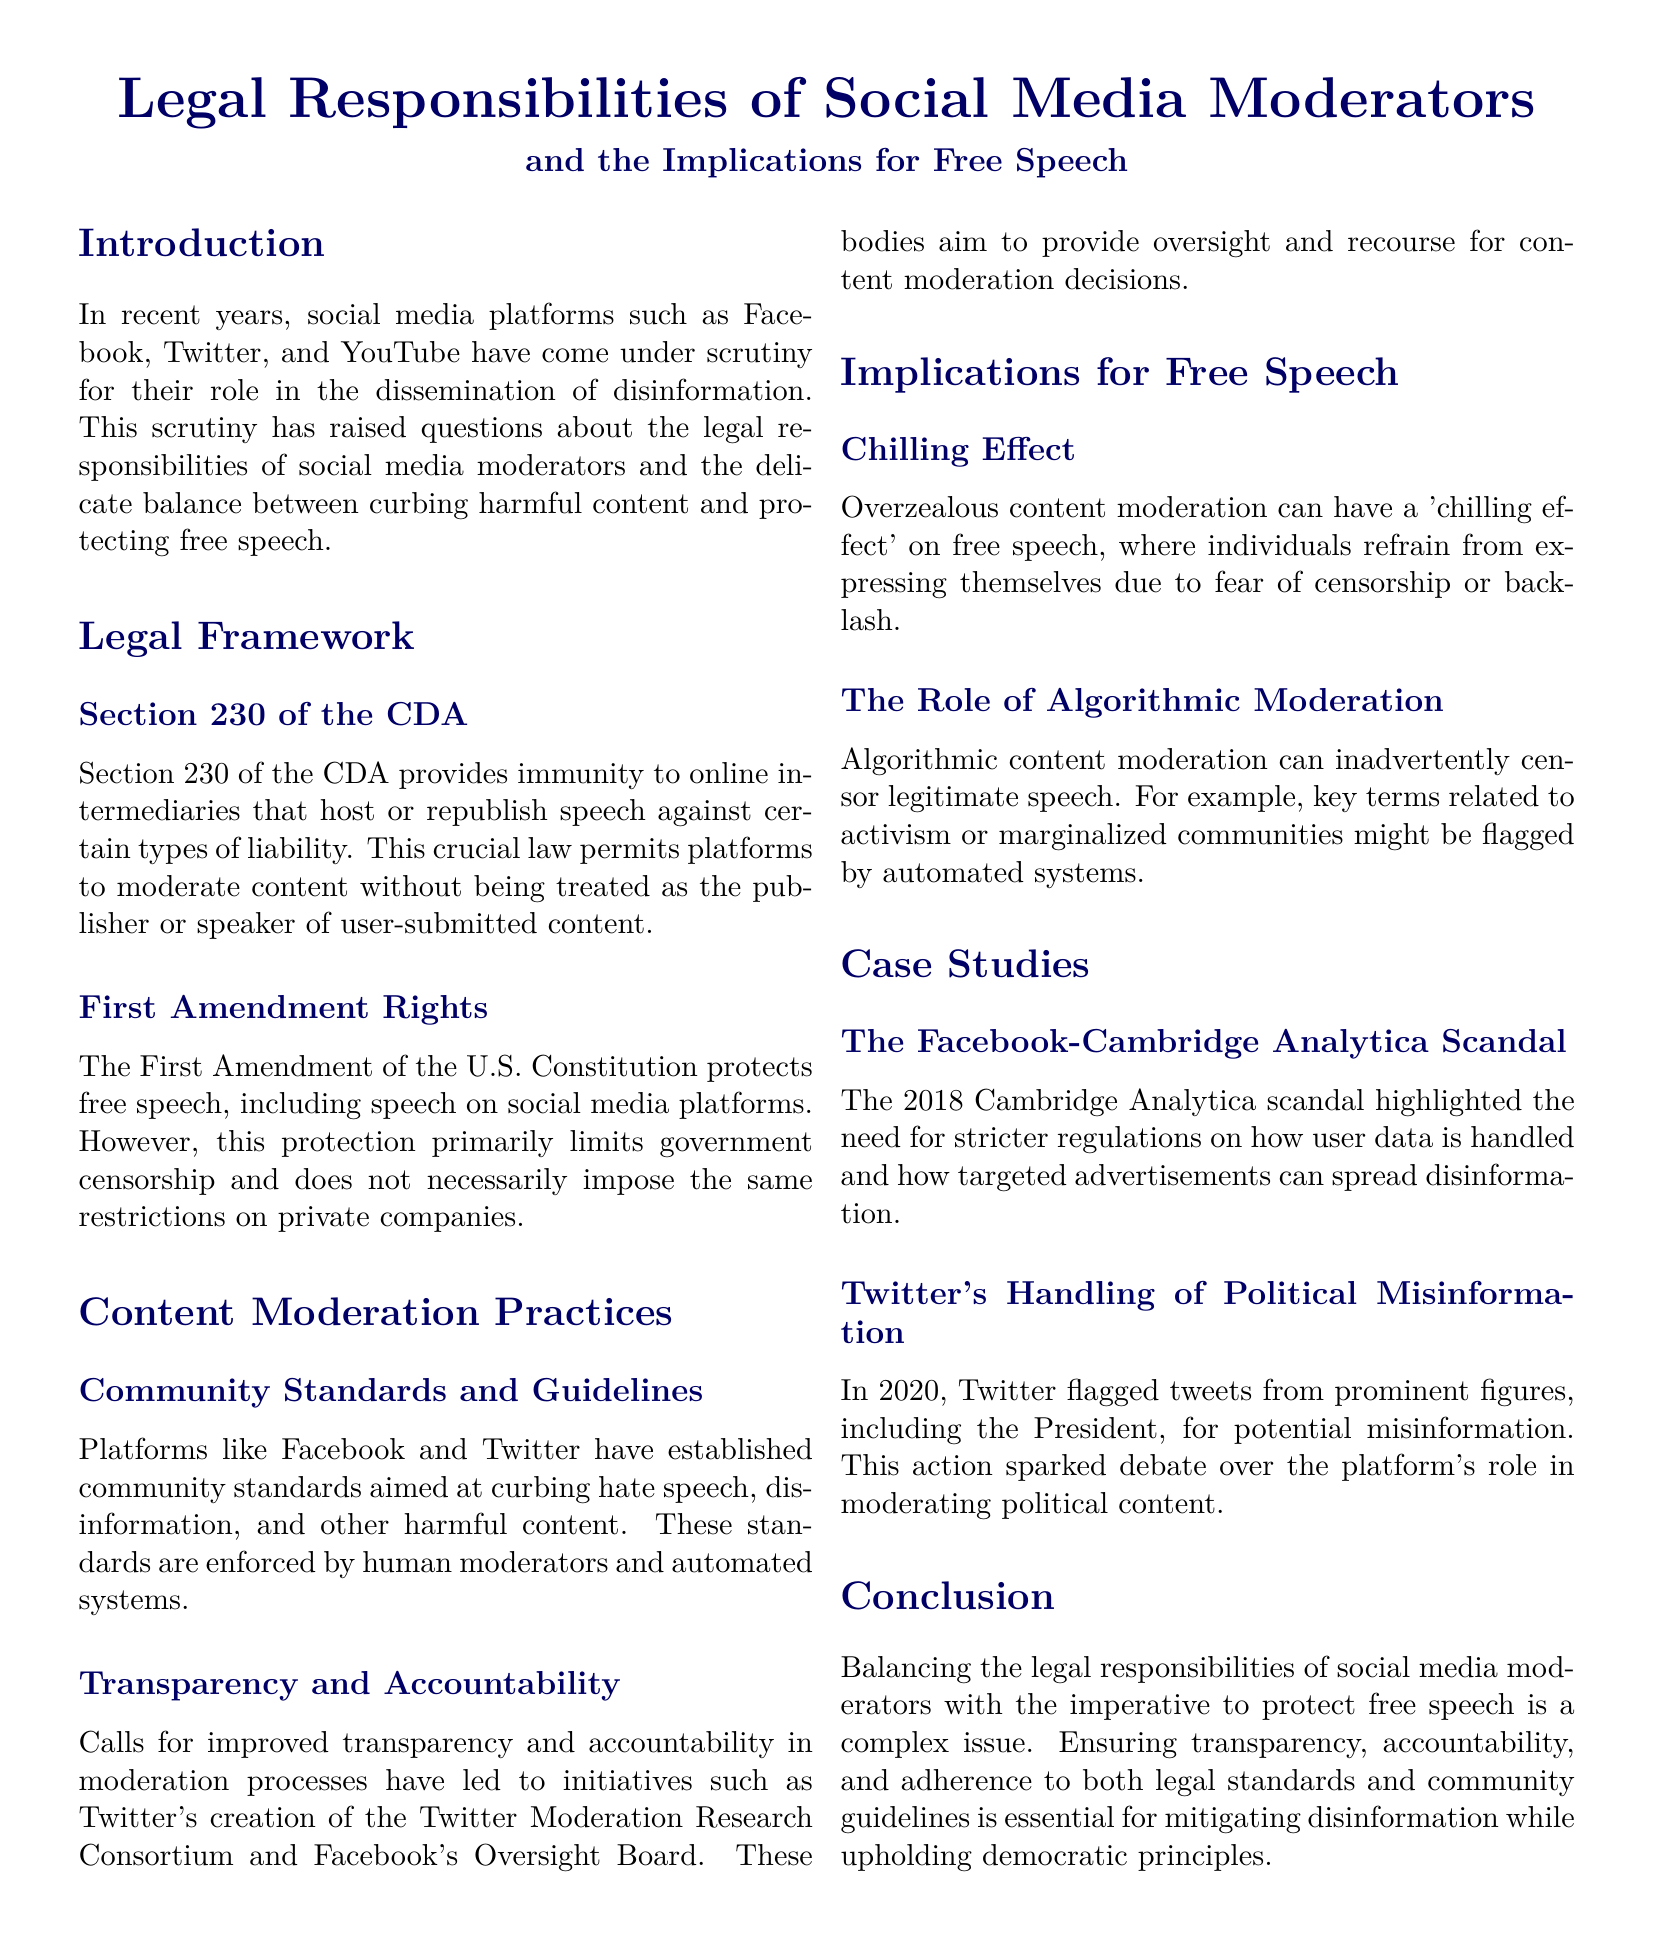What is the legal framework that provides immunity to online intermediaries? The legal framework that provides immunity to online intermediaries is Section 230 of the CDA.
Answer: Section 230 of the CDA What does the First Amendment primarily limit? The First Amendment primarily limits government censorship.
Answer: Government censorship What effect can overzealous content moderation have on free speech? Overzealous content moderation can have a 'chilling effect' on free speech.
Answer: Chilling effect What organization was created by Twitter to improve moderation transparency? Twitter's creation of the Twitter Moderation Research Consortium aims to improve moderation transparency.
Answer: Twitter Moderation Research Consortium In what year did the Cambridge Analytica scandal occur? The Cambridge Analytica scandal occurred in 2018.
Answer: 2018 What is one risk associated with algorithmic content moderation? Algorithmic content moderation can inadvertently censor legitimate speech.
Answer: Inadvertently censor legitimate speech What does the conclusion highlight as essential in addressing disinformation? The conclusion highlights transparency, accountability, and adherence to standards as essential.
Answer: Transparency, accountability, and adherence to standards Which social media platform flagged tweets for potential misinformation in 2020? Twitter flagged tweets for potential misinformation in 2020.
Answer: Twitter 